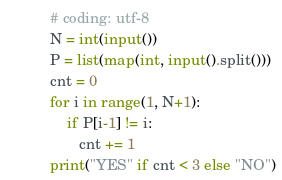Convert code to text. <code><loc_0><loc_0><loc_500><loc_500><_Python_># coding: utf-8
N = int(input())
P = list(map(int, input().split()))
cnt = 0
for i in range(1, N+1):
    if P[i-1] != i:
       cnt += 1 
print("YES" if cnt < 3 else "NO")</code> 